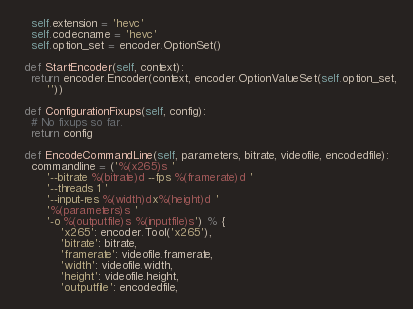<code> <loc_0><loc_0><loc_500><loc_500><_Python_>    self.extension = 'hevc'
    self.codecname = 'hevc'
    self.option_set = encoder.OptionSet()

  def StartEncoder(self, context):
    return encoder.Encoder(context, encoder.OptionValueSet(self.option_set,
        ''))

  def ConfigurationFixups(self, config):
    # No fixups so far.
    return config

  def EncodeCommandLine(self, parameters, bitrate, videofile, encodedfile):
    commandline = ('%(x265)s '
        '--bitrate %(bitrate)d --fps %(framerate)d '
        '--threads 1 '
        '--input-res %(width)dx%(height)d '
        '%(parameters)s '
        '-o %(outputfile)s %(inputfile)s') % {
            'x265': encoder.Tool('x265'),
            'bitrate': bitrate,
            'framerate': videofile.framerate,
            'width': videofile.width,
            'height': videofile.height,
            'outputfile': encodedfile,</code> 